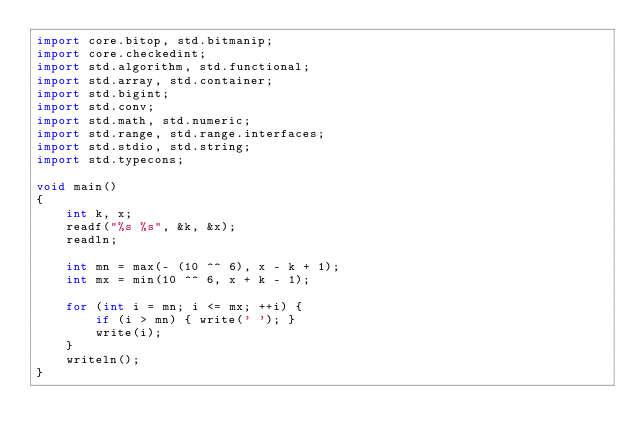Convert code to text. <code><loc_0><loc_0><loc_500><loc_500><_D_>import core.bitop, std.bitmanip;
import core.checkedint;
import std.algorithm, std.functional;
import std.array, std.container;
import std.bigint;
import std.conv;
import std.math, std.numeric;
import std.range, std.range.interfaces;
import std.stdio, std.string;
import std.typecons;

void main()
{
    int k, x;
    readf("%s %s", &k, &x);
    readln;
    
    int mn = max(- (10 ^^ 6), x - k + 1);
    int mx = min(10 ^^ 6, x + k - 1);
    
    for (int i = mn; i <= mx; ++i) {
        if (i > mn) { write(' '); }
        write(i);
    }
    writeln();
}</code> 